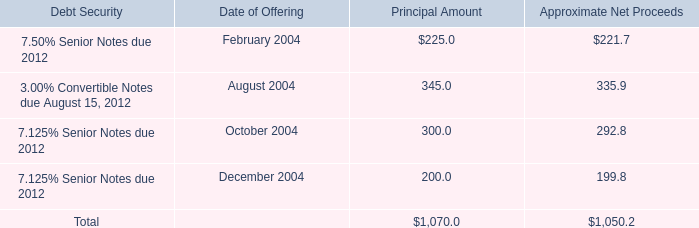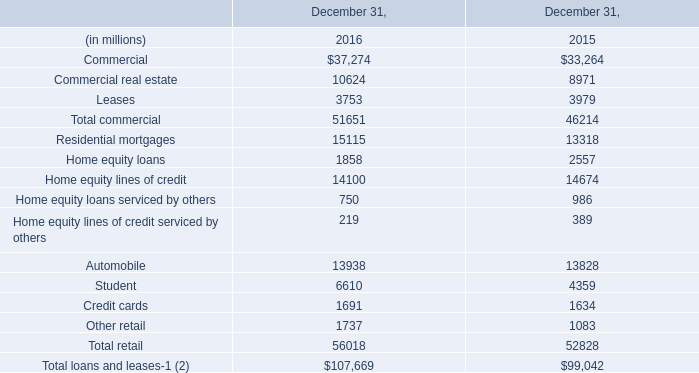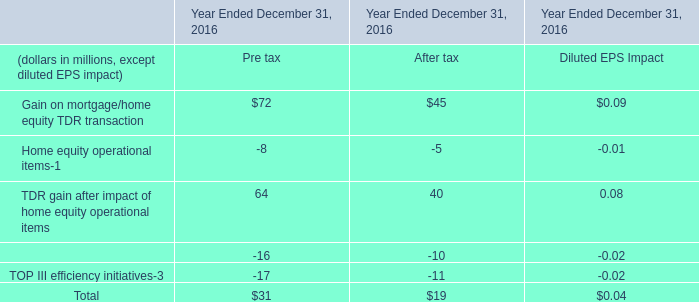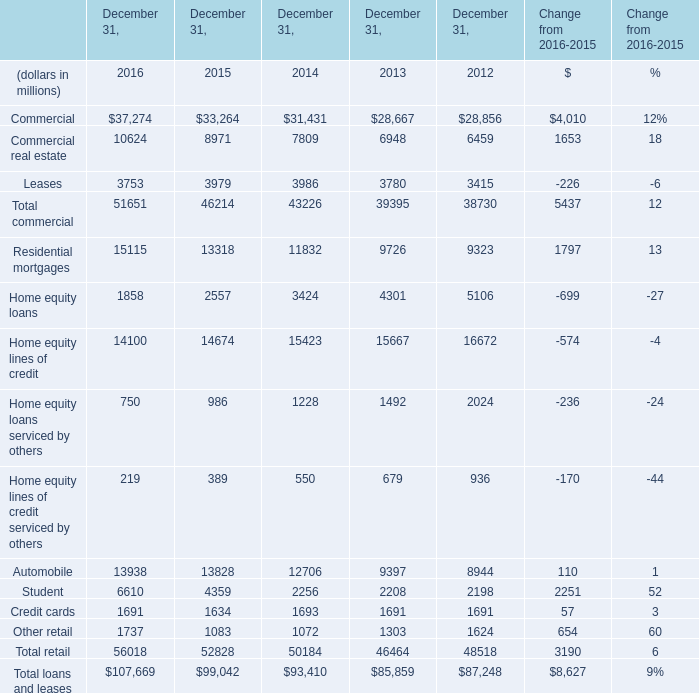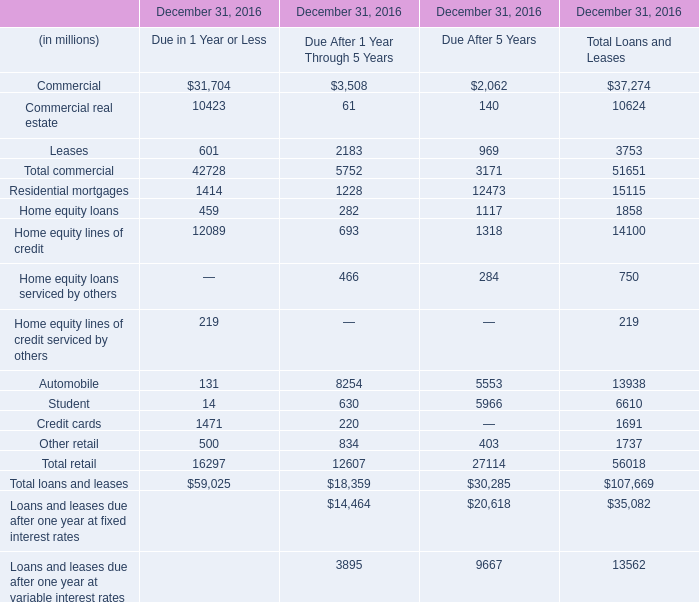What's the sum of Commercial real estate of December 31, 2015, and Automobile of December 31, 2012 ? 
Computations: (8971.0 + 8944.0)
Answer: 17915.0. 